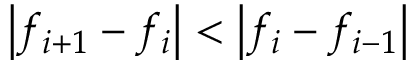Convert formula to latex. <formula><loc_0><loc_0><loc_500><loc_500>\left | f _ { i + 1 } - f _ { i } \right | < \left | f _ { i } - f _ { i - 1 } \right |</formula> 